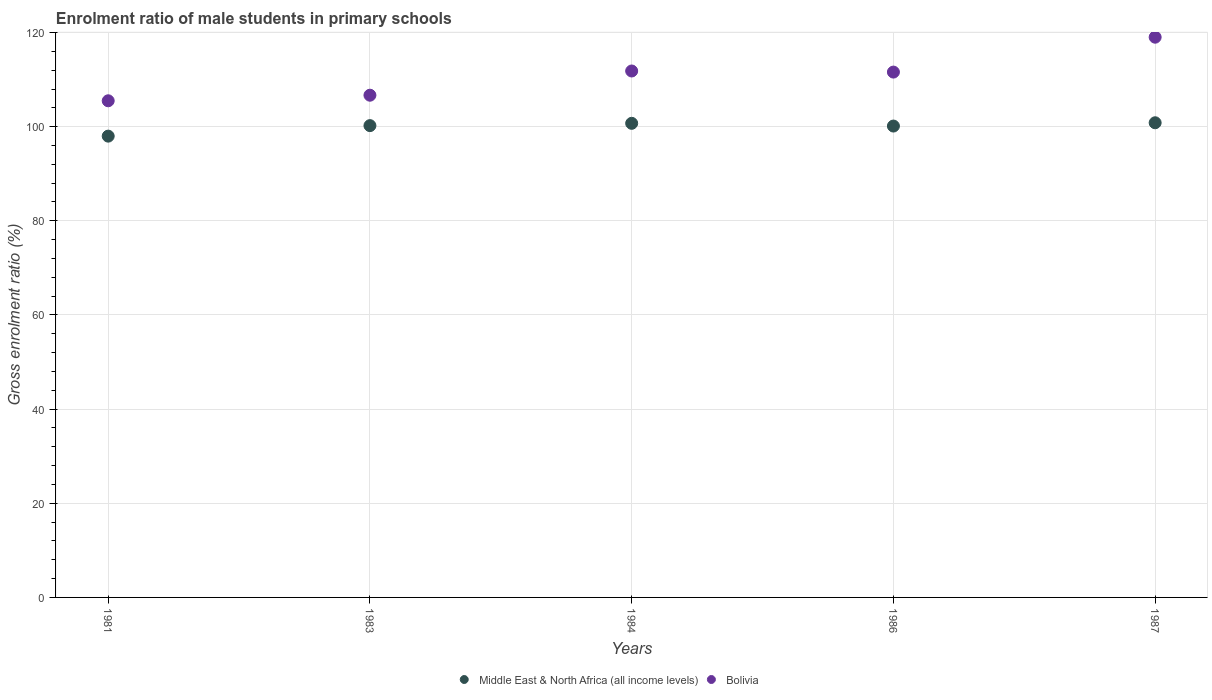How many different coloured dotlines are there?
Give a very brief answer. 2. Is the number of dotlines equal to the number of legend labels?
Give a very brief answer. Yes. What is the enrolment ratio of male students in primary schools in Middle East & North Africa (all income levels) in 1987?
Make the answer very short. 100.83. Across all years, what is the maximum enrolment ratio of male students in primary schools in Bolivia?
Keep it short and to the point. 119.01. Across all years, what is the minimum enrolment ratio of male students in primary schools in Middle East & North Africa (all income levels)?
Make the answer very short. 97.99. In which year was the enrolment ratio of male students in primary schools in Middle East & North Africa (all income levels) maximum?
Offer a very short reply. 1987. In which year was the enrolment ratio of male students in primary schools in Bolivia minimum?
Make the answer very short. 1981. What is the total enrolment ratio of male students in primary schools in Bolivia in the graph?
Your answer should be compact. 554.61. What is the difference between the enrolment ratio of male students in primary schools in Middle East & North Africa (all income levels) in 1983 and that in 1986?
Your answer should be very brief. 0.09. What is the difference between the enrolment ratio of male students in primary schools in Bolivia in 1984 and the enrolment ratio of male students in primary schools in Middle East & North Africa (all income levels) in 1986?
Your answer should be very brief. 11.7. What is the average enrolment ratio of male students in primary schools in Bolivia per year?
Offer a very short reply. 110.92. In the year 1986, what is the difference between the enrolment ratio of male students in primary schools in Bolivia and enrolment ratio of male students in primary schools in Middle East & North Africa (all income levels)?
Offer a very short reply. 11.46. What is the ratio of the enrolment ratio of male students in primary schools in Bolivia in 1981 to that in 1987?
Provide a succinct answer. 0.89. Is the enrolment ratio of male students in primary schools in Bolivia in 1984 less than that in 1986?
Give a very brief answer. No. Is the difference between the enrolment ratio of male students in primary schools in Bolivia in 1986 and 1987 greater than the difference between the enrolment ratio of male students in primary schools in Middle East & North Africa (all income levels) in 1986 and 1987?
Offer a very short reply. No. What is the difference between the highest and the second highest enrolment ratio of male students in primary schools in Middle East & North Africa (all income levels)?
Offer a very short reply. 0.12. What is the difference between the highest and the lowest enrolment ratio of male students in primary schools in Middle East & North Africa (all income levels)?
Keep it short and to the point. 2.84. In how many years, is the enrolment ratio of male students in primary schools in Middle East & North Africa (all income levels) greater than the average enrolment ratio of male students in primary schools in Middle East & North Africa (all income levels) taken over all years?
Keep it short and to the point. 4. Does the enrolment ratio of male students in primary schools in Bolivia monotonically increase over the years?
Your answer should be very brief. No. Is the enrolment ratio of male students in primary schools in Bolivia strictly less than the enrolment ratio of male students in primary schools in Middle East & North Africa (all income levels) over the years?
Give a very brief answer. No. How many dotlines are there?
Keep it short and to the point. 2. How many years are there in the graph?
Offer a very short reply. 5. Are the values on the major ticks of Y-axis written in scientific E-notation?
Give a very brief answer. No. Does the graph contain any zero values?
Give a very brief answer. No. How many legend labels are there?
Make the answer very short. 2. How are the legend labels stacked?
Your response must be concise. Horizontal. What is the title of the graph?
Your response must be concise. Enrolment ratio of male students in primary schools. What is the label or title of the Y-axis?
Keep it short and to the point. Gross enrolment ratio (%). What is the Gross enrolment ratio (%) of Middle East & North Africa (all income levels) in 1981?
Provide a succinct answer. 97.99. What is the Gross enrolment ratio (%) of Bolivia in 1981?
Your answer should be compact. 105.5. What is the Gross enrolment ratio (%) in Middle East & North Africa (all income levels) in 1983?
Your answer should be very brief. 100.22. What is the Gross enrolment ratio (%) in Bolivia in 1983?
Keep it short and to the point. 106.68. What is the Gross enrolment ratio (%) of Middle East & North Africa (all income levels) in 1984?
Your answer should be compact. 100.71. What is the Gross enrolment ratio (%) in Bolivia in 1984?
Your answer should be compact. 111.83. What is the Gross enrolment ratio (%) in Middle East & North Africa (all income levels) in 1986?
Offer a very short reply. 100.13. What is the Gross enrolment ratio (%) in Bolivia in 1986?
Make the answer very short. 111.6. What is the Gross enrolment ratio (%) in Middle East & North Africa (all income levels) in 1987?
Give a very brief answer. 100.83. What is the Gross enrolment ratio (%) of Bolivia in 1987?
Offer a very short reply. 119.01. Across all years, what is the maximum Gross enrolment ratio (%) of Middle East & North Africa (all income levels)?
Make the answer very short. 100.83. Across all years, what is the maximum Gross enrolment ratio (%) in Bolivia?
Provide a succinct answer. 119.01. Across all years, what is the minimum Gross enrolment ratio (%) in Middle East & North Africa (all income levels)?
Give a very brief answer. 97.99. Across all years, what is the minimum Gross enrolment ratio (%) of Bolivia?
Ensure brevity in your answer.  105.5. What is the total Gross enrolment ratio (%) of Middle East & North Africa (all income levels) in the graph?
Offer a terse response. 499.89. What is the total Gross enrolment ratio (%) in Bolivia in the graph?
Give a very brief answer. 554.61. What is the difference between the Gross enrolment ratio (%) of Middle East & North Africa (all income levels) in 1981 and that in 1983?
Provide a succinct answer. -2.23. What is the difference between the Gross enrolment ratio (%) in Bolivia in 1981 and that in 1983?
Keep it short and to the point. -1.18. What is the difference between the Gross enrolment ratio (%) in Middle East & North Africa (all income levels) in 1981 and that in 1984?
Your answer should be very brief. -2.72. What is the difference between the Gross enrolment ratio (%) of Bolivia in 1981 and that in 1984?
Your response must be concise. -6.33. What is the difference between the Gross enrolment ratio (%) of Middle East & North Africa (all income levels) in 1981 and that in 1986?
Ensure brevity in your answer.  -2.14. What is the difference between the Gross enrolment ratio (%) of Bolivia in 1981 and that in 1986?
Keep it short and to the point. -6.1. What is the difference between the Gross enrolment ratio (%) in Middle East & North Africa (all income levels) in 1981 and that in 1987?
Offer a terse response. -2.84. What is the difference between the Gross enrolment ratio (%) in Bolivia in 1981 and that in 1987?
Offer a very short reply. -13.51. What is the difference between the Gross enrolment ratio (%) in Middle East & North Africa (all income levels) in 1983 and that in 1984?
Offer a very short reply. -0.49. What is the difference between the Gross enrolment ratio (%) of Bolivia in 1983 and that in 1984?
Your response must be concise. -5.14. What is the difference between the Gross enrolment ratio (%) in Middle East & North Africa (all income levels) in 1983 and that in 1986?
Ensure brevity in your answer.  0.09. What is the difference between the Gross enrolment ratio (%) in Bolivia in 1983 and that in 1986?
Your response must be concise. -4.91. What is the difference between the Gross enrolment ratio (%) of Middle East & North Africa (all income levels) in 1983 and that in 1987?
Offer a very short reply. -0.61. What is the difference between the Gross enrolment ratio (%) of Bolivia in 1983 and that in 1987?
Make the answer very short. -12.32. What is the difference between the Gross enrolment ratio (%) in Middle East & North Africa (all income levels) in 1984 and that in 1986?
Your response must be concise. 0.58. What is the difference between the Gross enrolment ratio (%) in Bolivia in 1984 and that in 1986?
Your answer should be very brief. 0.23. What is the difference between the Gross enrolment ratio (%) in Middle East & North Africa (all income levels) in 1984 and that in 1987?
Provide a short and direct response. -0.12. What is the difference between the Gross enrolment ratio (%) in Bolivia in 1984 and that in 1987?
Make the answer very short. -7.18. What is the difference between the Gross enrolment ratio (%) in Middle East & North Africa (all income levels) in 1986 and that in 1987?
Provide a short and direct response. -0.7. What is the difference between the Gross enrolment ratio (%) in Bolivia in 1986 and that in 1987?
Your answer should be very brief. -7.41. What is the difference between the Gross enrolment ratio (%) in Middle East & North Africa (all income levels) in 1981 and the Gross enrolment ratio (%) in Bolivia in 1983?
Your answer should be very brief. -8.69. What is the difference between the Gross enrolment ratio (%) in Middle East & North Africa (all income levels) in 1981 and the Gross enrolment ratio (%) in Bolivia in 1984?
Your answer should be compact. -13.84. What is the difference between the Gross enrolment ratio (%) of Middle East & North Africa (all income levels) in 1981 and the Gross enrolment ratio (%) of Bolivia in 1986?
Your answer should be compact. -13.61. What is the difference between the Gross enrolment ratio (%) of Middle East & North Africa (all income levels) in 1981 and the Gross enrolment ratio (%) of Bolivia in 1987?
Offer a very short reply. -21.02. What is the difference between the Gross enrolment ratio (%) of Middle East & North Africa (all income levels) in 1983 and the Gross enrolment ratio (%) of Bolivia in 1984?
Offer a very short reply. -11.6. What is the difference between the Gross enrolment ratio (%) in Middle East & North Africa (all income levels) in 1983 and the Gross enrolment ratio (%) in Bolivia in 1986?
Make the answer very short. -11.37. What is the difference between the Gross enrolment ratio (%) in Middle East & North Africa (all income levels) in 1983 and the Gross enrolment ratio (%) in Bolivia in 1987?
Give a very brief answer. -18.78. What is the difference between the Gross enrolment ratio (%) of Middle East & North Africa (all income levels) in 1984 and the Gross enrolment ratio (%) of Bolivia in 1986?
Ensure brevity in your answer.  -10.88. What is the difference between the Gross enrolment ratio (%) of Middle East & North Africa (all income levels) in 1984 and the Gross enrolment ratio (%) of Bolivia in 1987?
Give a very brief answer. -18.3. What is the difference between the Gross enrolment ratio (%) of Middle East & North Africa (all income levels) in 1986 and the Gross enrolment ratio (%) of Bolivia in 1987?
Your answer should be very brief. -18.87. What is the average Gross enrolment ratio (%) in Middle East & North Africa (all income levels) per year?
Make the answer very short. 99.98. What is the average Gross enrolment ratio (%) in Bolivia per year?
Your response must be concise. 110.92. In the year 1981, what is the difference between the Gross enrolment ratio (%) of Middle East & North Africa (all income levels) and Gross enrolment ratio (%) of Bolivia?
Your answer should be very brief. -7.51. In the year 1983, what is the difference between the Gross enrolment ratio (%) in Middle East & North Africa (all income levels) and Gross enrolment ratio (%) in Bolivia?
Offer a terse response. -6.46. In the year 1984, what is the difference between the Gross enrolment ratio (%) of Middle East & North Africa (all income levels) and Gross enrolment ratio (%) of Bolivia?
Your answer should be very brief. -11.12. In the year 1986, what is the difference between the Gross enrolment ratio (%) of Middle East & North Africa (all income levels) and Gross enrolment ratio (%) of Bolivia?
Provide a short and direct response. -11.46. In the year 1987, what is the difference between the Gross enrolment ratio (%) in Middle East & North Africa (all income levels) and Gross enrolment ratio (%) in Bolivia?
Offer a terse response. -18.18. What is the ratio of the Gross enrolment ratio (%) of Middle East & North Africa (all income levels) in 1981 to that in 1983?
Make the answer very short. 0.98. What is the ratio of the Gross enrolment ratio (%) of Bolivia in 1981 to that in 1983?
Provide a short and direct response. 0.99. What is the ratio of the Gross enrolment ratio (%) of Bolivia in 1981 to that in 1984?
Provide a short and direct response. 0.94. What is the ratio of the Gross enrolment ratio (%) in Middle East & North Africa (all income levels) in 1981 to that in 1986?
Your response must be concise. 0.98. What is the ratio of the Gross enrolment ratio (%) of Bolivia in 1981 to that in 1986?
Your answer should be very brief. 0.95. What is the ratio of the Gross enrolment ratio (%) of Middle East & North Africa (all income levels) in 1981 to that in 1987?
Keep it short and to the point. 0.97. What is the ratio of the Gross enrolment ratio (%) of Bolivia in 1981 to that in 1987?
Ensure brevity in your answer.  0.89. What is the ratio of the Gross enrolment ratio (%) of Bolivia in 1983 to that in 1984?
Make the answer very short. 0.95. What is the ratio of the Gross enrolment ratio (%) of Middle East & North Africa (all income levels) in 1983 to that in 1986?
Provide a succinct answer. 1. What is the ratio of the Gross enrolment ratio (%) in Bolivia in 1983 to that in 1986?
Your answer should be compact. 0.96. What is the ratio of the Gross enrolment ratio (%) in Middle East & North Africa (all income levels) in 1983 to that in 1987?
Your response must be concise. 0.99. What is the ratio of the Gross enrolment ratio (%) of Bolivia in 1983 to that in 1987?
Keep it short and to the point. 0.9. What is the ratio of the Gross enrolment ratio (%) in Bolivia in 1984 to that in 1987?
Make the answer very short. 0.94. What is the ratio of the Gross enrolment ratio (%) in Bolivia in 1986 to that in 1987?
Give a very brief answer. 0.94. What is the difference between the highest and the second highest Gross enrolment ratio (%) of Middle East & North Africa (all income levels)?
Give a very brief answer. 0.12. What is the difference between the highest and the second highest Gross enrolment ratio (%) of Bolivia?
Offer a terse response. 7.18. What is the difference between the highest and the lowest Gross enrolment ratio (%) in Middle East & North Africa (all income levels)?
Give a very brief answer. 2.84. What is the difference between the highest and the lowest Gross enrolment ratio (%) in Bolivia?
Keep it short and to the point. 13.51. 